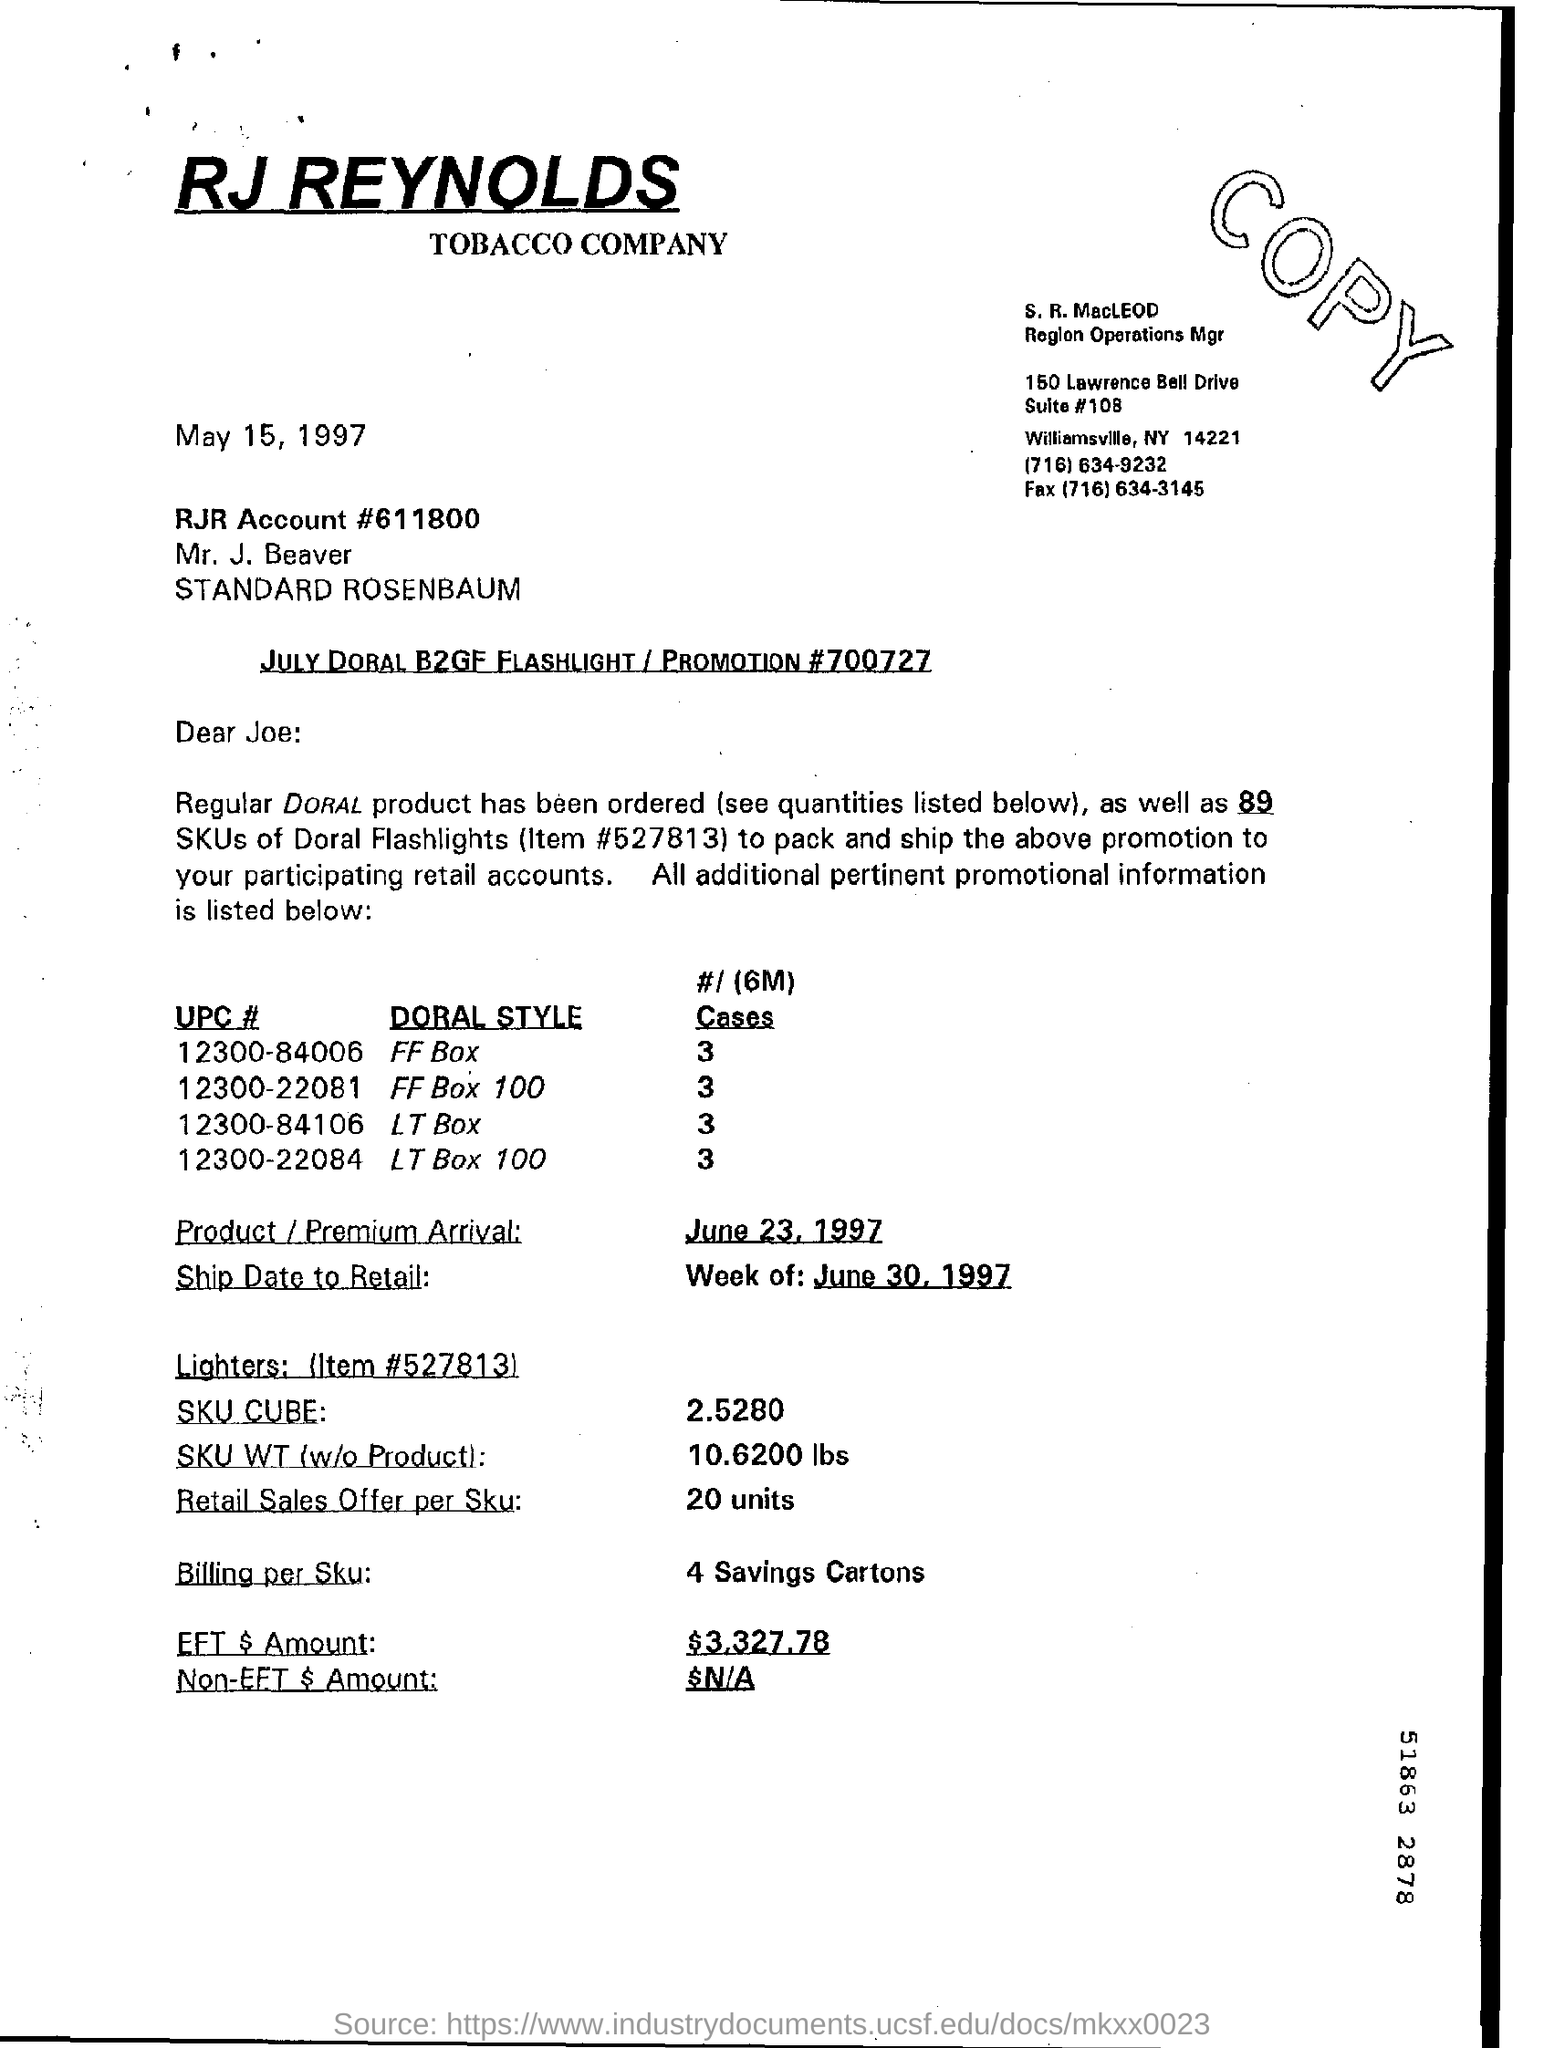Which company is mentioned in the letter head?
Provide a succinct answer. RJ Reynolds Tobacco Company. When is the Product /Premium Arrival dated?
Give a very brief answer. June 23, 1997. What is SKU WT(w/o Product) ?
Keep it short and to the point. 10.6200 lbs. How much is the EFT $ Amount?
Provide a succinct answer. 3,327.78. What is the Retail Sales Offer per SKU?
Offer a very short reply. 20 units. 